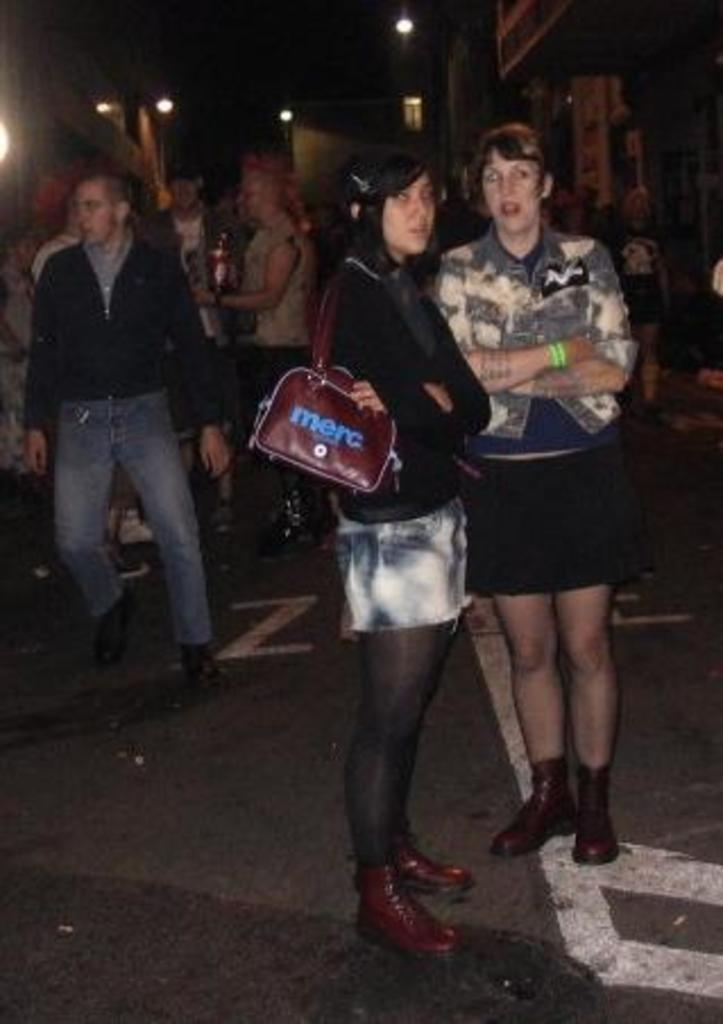What are the people in the image doing? The people in the image are standing on the road. What can be seen in the distance behind the people? There are buildings and lights visible in the background of the image. How many spiders are crawling on the people in the image? There are no spiders visible in the image; the people are standing on the road with no spiders present. 